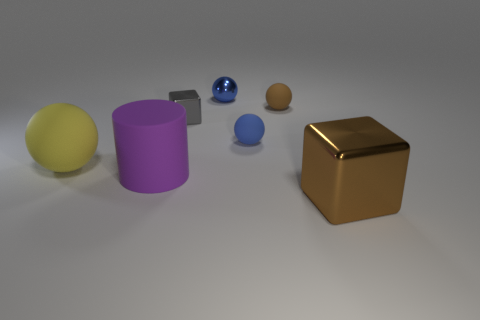Subtract all blue rubber balls. How many balls are left? 3 Subtract all green cylinders. How many blue spheres are left? 2 Subtract all brown balls. How many balls are left? 3 Subtract all red balls. Subtract all cyan cylinders. How many balls are left? 4 Subtract all balls. How many objects are left? 3 Add 1 tiny brown matte spheres. How many objects exist? 8 Add 1 blue things. How many blue things are left? 3 Add 2 blue metal things. How many blue metal things exist? 3 Subtract 0 green cylinders. How many objects are left? 7 Subtract all large purple objects. Subtract all large cylinders. How many objects are left? 5 